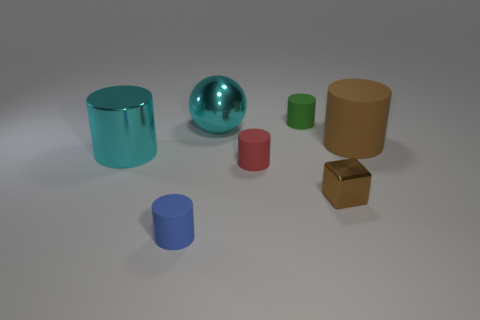Is there anything else that is the same shape as the tiny brown object?
Give a very brief answer. No. Is the tiny green thing made of the same material as the tiny red cylinder that is in front of the cyan shiny cylinder?
Ensure brevity in your answer.  Yes. Are there fewer tiny blue objects that are behind the tiny green cylinder than tiny brown objects?
Your answer should be very brief. Yes. What number of other objects are there of the same shape as the tiny green matte object?
Provide a succinct answer. 4. Is there any other thing that is the same color as the small cube?
Your response must be concise. Yes. Is the color of the big metal sphere the same as the large metal thing in front of the large brown object?
Ensure brevity in your answer.  Yes. What number of other things are there of the same size as the metal sphere?
Your answer should be very brief. 2. There is another thing that is the same color as the big rubber thing; what size is it?
Ensure brevity in your answer.  Small. How many spheres are either tiny brown metal things or big brown matte objects?
Your answer should be compact. 0. There is a large thing on the right side of the small green matte cylinder; is it the same shape as the small brown metal object?
Keep it short and to the point. No. 